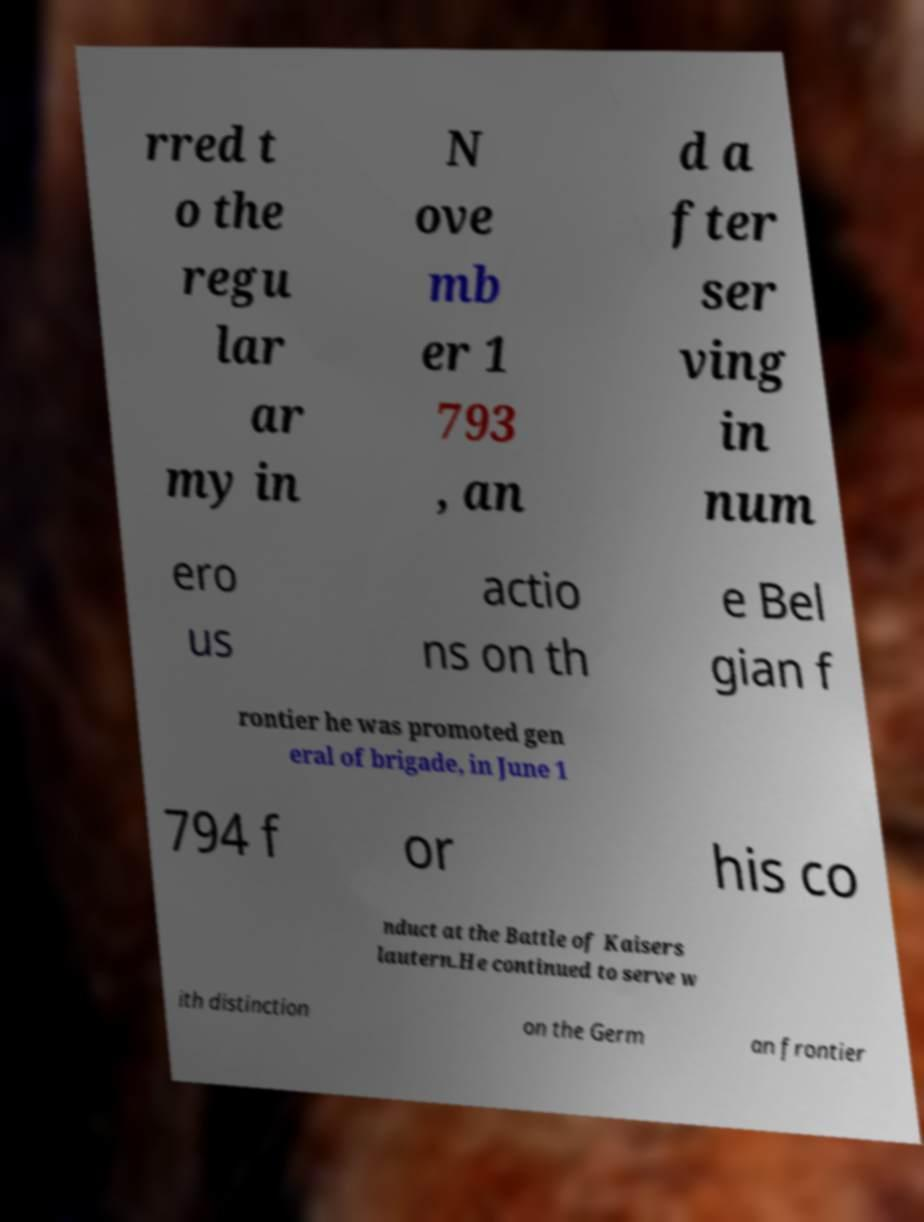There's text embedded in this image that I need extracted. Can you transcribe it verbatim? rred t o the regu lar ar my in N ove mb er 1 793 , an d a fter ser ving in num ero us actio ns on th e Bel gian f rontier he was promoted gen eral of brigade, in June 1 794 f or his co nduct at the Battle of Kaisers lautern.He continued to serve w ith distinction on the Germ an frontier 